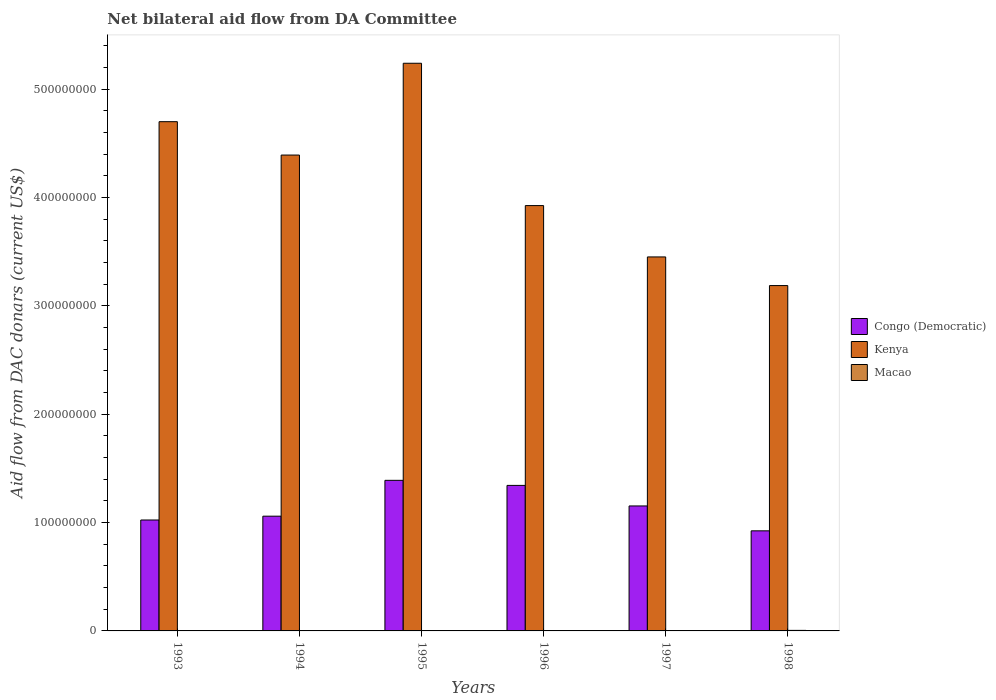Are the number of bars per tick equal to the number of legend labels?
Keep it short and to the point. Yes. How many bars are there on the 3rd tick from the right?
Provide a short and direct response. 3. What is the label of the 5th group of bars from the left?
Provide a short and direct response. 1997. In how many cases, is the number of bars for a given year not equal to the number of legend labels?
Your answer should be very brief. 0. What is the aid flow in in Kenya in 1997?
Ensure brevity in your answer.  3.45e+08. Across all years, what is the maximum aid flow in in Congo (Democratic)?
Your response must be concise. 1.39e+08. Across all years, what is the minimum aid flow in in Congo (Democratic)?
Provide a succinct answer. 9.24e+07. In which year was the aid flow in in Congo (Democratic) maximum?
Provide a short and direct response. 1995. What is the total aid flow in in Congo (Democratic) in the graph?
Provide a succinct answer. 6.89e+08. What is the difference between the aid flow in in Macao in 1993 and that in 1996?
Your answer should be compact. -1.40e+05. What is the difference between the aid flow in in Macao in 1996 and the aid flow in in Kenya in 1994?
Provide a succinct answer. -4.39e+08. What is the average aid flow in in Congo (Democratic) per year?
Provide a short and direct response. 1.15e+08. In the year 1994, what is the difference between the aid flow in in Kenya and aid flow in in Congo (Democratic)?
Ensure brevity in your answer.  3.33e+08. What is the ratio of the aid flow in in Kenya in 1995 to that in 1997?
Provide a short and direct response. 1.52. Is the difference between the aid flow in in Kenya in 1993 and 1995 greater than the difference between the aid flow in in Congo (Democratic) in 1993 and 1995?
Keep it short and to the point. No. What is the difference between the highest and the second highest aid flow in in Congo (Democratic)?
Make the answer very short. 4.68e+06. What is the difference between the highest and the lowest aid flow in in Kenya?
Give a very brief answer. 2.05e+08. What does the 1st bar from the left in 1998 represents?
Provide a succinct answer. Congo (Democratic). What does the 2nd bar from the right in 1996 represents?
Your response must be concise. Kenya. How many bars are there?
Make the answer very short. 18. Are all the bars in the graph horizontal?
Give a very brief answer. No. How many years are there in the graph?
Offer a terse response. 6. What is the difference between two consecutive major ticks on the Y-axis?
Offer a very short reply. 1.00e+08. Does the graph contain any zero values?
Your answer should be very brief. No. Does the graph contain grids?
Keep it short and to the point. No. How many legend labels are there?
Give a very brief answer. 3. How are the legend labels stacked?
Your answer should be very brief. Vertical. What is the title of the graph?
Your answer should be very brief. Net bilateral aid flow from DA Committee. What is the label or title of the Y-axis?
Your answer should be compact. Aid flow from DAC donars (current US$). What is the Aid flow from DAC donars (current US$) in Congo (Democratic) in 1993?
Your answer should be very brief. 1.02e+08. What is the Aid flow from DAC donars (current US$) in Kenya in 1993?
Provide a short and direct response. 4.70e+08. What is the Aid flow from DAC donars (current US$) of Congo (Democratic) in 1994?
Offer a very short reply. 1.06e+08. What is the Aid flow from DAC donars (current US$) in Kenya in 1994?
Provide a short and direct response. 4.39e+08. What is the Aid flow from DAC donars (current US$) of Macao in 1994?
Provide a short and direct response. 2.70e+05. What is the Aid flow from DAC donars (current US$) in Congo (Democratic) in 1995?
Offer a very short reply. 1.39e+08. What is the Aid flow from DAC donars (current US$) in Kenya in 1995?
Provide a short and direct response. 5.24e+08. What is the Aid flow from DAC donars (current US$) in Macao in 1995?
Offer a very short reply. 1.40e+05. What is the Aid flow from DAC donars (current US$) in Congo (Democratic) in 1996?
Give a very brief answer. 1.34e+08. What is the Aid flow from DAC donars (current US$) in Kenya in 1996?
Provide a short and direct response. 3.93e+08. What is the Aid flow from DAC donars (current US$) of Macao in 1996?
Your response must be concise. 2.90e+05. What is the Aid flow from DAC donars (current US$) in Congo (Democratic) in 1997?
Ensure brevity in your answer.  1.15e+08. What is the Aid flow from DAC donars (current US$) in Kenya in 1997?
Make the answer very short. 3.45e+08. What is the Aid flow from DAC donars (current US$) in Macao in 1997?
Offer a terse response. 3.10e+05. What is the Aid flow from DAC donars (current US$) of Congo (Democratic) in 1998?
Offer a terse response. 9.24e+07. What is the Aid flow from DAC donars (current US$) of Kenya in 1998?
Provide a short and direct response. 3.19e+08. What is the Aid flow from DAC donars (current US$) of Macao in 1998?
Offer a very short reply. 5.00e+05. Across all years, what is the maximum Aid flow from DAC donars (current US$) in Congo (Democratic)?
Offer a very short reply. 1.39e+08. Across all years, what is the maximum Aid flow from DAC donars (current US$) in Kenya?
Your answer should be compact. 5.24e+08. Across all years, what is the minimum Aid flow from DAC donars (current US$) in Congo (Democratic)?
Offer a very short reply. 9.24e+07. Across all years, what is the minimum Aid flow from DAC donars (current US$) in Kenya?
Your answer should be compact. 3.19e+08. What is the total Aid flow from DAC donars (current US$) in Congo (Democratic) in the graph?
Provide a short and direct response. 6.89e+08. What is the total Aid flow from DAC donars (current US$) in Kenya in the graph?
Ensure brevity in your answer.  2.49e+09. What is the total Aid flow from DAC donars (current US$) in Macao in the graph?
Ensure brevity in your answer.  1.66e+06. What is the difference between the Aid flow from DAC donars (current US$) in Congo (Democratic) in 1993 and that in 1994?
Your answer should be very brief. -3.52e+06. What is the difference between the Aid flow from DAC donars (current US$) of Kenya in 1993 and that in 1994?
Keep it short and to the point. 3.08e+07. What is the difference between the Aid flow from DAC donars (current US$) of Congo (Democratic) in 1993 and that in 1995?
Provide a succinct answer. -3.66e+07. What is the difference between the Aid flow from DAC donars (current US$) in Kenya in 1993 and that in 1995?
Provide a succinct answer. -5.39e+07. What is the difference between the Aid flow from DAC donars (current US$) in Congo (Democratic) in 1993 and that in 1996?
Offer a terse response. -3.19e+07. What is the difference between the Aid flow from DAC donars (current US$) of Kenya in 1993 and that in 1996?
Ensure brevity in your answer.  7.74e+07. What is the difference between the Aid flow from DAC donars (current US$) in Congo (Democratic) in 1993 and that in 1997?
Offer a very short reply. -1.30e+07. What is the difference between the Aid flow from DAC donars (current US$) in Kenya in 1993 and that in 1997?
Ensure brevity in your answer.  1.25e+08. What is the difference between the Aid flow from DAC donars (current US$) in Macao in 1993 and that in 1997?
Provide a succinct answer. -1.60e+05. What is the difference between the Aid flow from DAC donars (current US$) in Congo (Democratic) in 1993 and that in 1998?
Provide a succinct answer. 1.00e+07. What is the difference between the Aid flow from DAC donars (current US$) of Kenya in 1993 and that in 1998?
Your answer should be compact. 1.51e+08. What is the difference between the Aid flow from DAC donars (current US$) in Macao in 1993 and that in 1998?
Give a very brief answer. -3.50e+05. What is the difference between the Aid flow from DAC donars (current US$) of Congo (Democratic) in 1994 and that in 1995?
Give a very brief answer. -3.31e+07. What is the difference between the Aid flow from DAC donars (current US$) of Kenya in 1994 and that in 1995?
Your answer should be very brief. -8.47e+07. What is the difference between the Aid flow from DAC donars (current US$) of Macao in 1994 and that in 1995?
Keep it short and to the point. 1.30e+05. What is the difference between the Aid flow from DAC donars (current US$) in Congo (Democratic) in 1994 and that in 1996?
Your response must be concise. -2.84e+07. What is the difference between the Aid flow from DAC donars (current US$) in Kenya in 1994 and that in 1996?
Ensure brevity in your answer.  4.66e+07. What is the difference between the Aid flow from DAC donars (current US$) in Macao in 1994 and that in 1996?
Provide a short and direct response. -2.00e+04. What is the difference between the Aid flow from DAC donars (current US$) in Congo (Democratic) in 1994 and that in 1997?
Provide a succinct answer. -9.44e+06. What is the difference between the Aid flow from DAC donars (current US$) of Kenya in 1994 and that in 1997?
Provide a short and direct response. 9.40e+07. What is the difference between the Aid flow from DAC donars (current US$) of Macao in 1994 and that in 1997?
Keep it short and to the point. -4.00e+04. What is the difference between the Aid flow from DAC donars (current US$) of Congo (Democratic) in 1994 and that in 1998?
Give a very brief answer. 1.35e+07. What is the difference between the Aid flow from DAC donars (current US$) of Kenya in 1994 and that in 1998?
Make the answer very short. 1.20e+08. What is the difference between the Aid flow from DAC donars (current US$) of Macao in 1994 and that in 1998?
Offer a terse response. -2.30e+05. What is the difference between the Aid flow from DAC donars (current US$) in Congo (Democratic) in 1995 and that in 1996?
Ensure brevity in your answer.  4.68e+06. What is the difference between the Aid flow from DAC donars (current US$) of Kenya in 1995 and that in 1996?
Make the answer very short. 1.31e+08. What is the difference between the Aid flow from DAC donars (current US$) of Macao in 1995 and that in 1996?
Your response must be concise. -1.50e+05. What is the difference between the Aid flow from DAC donars (current US$) in Congo (Democratic) in 1995 and that in 1997?
Provide a succinct answer. 2.36e+07. What is the difference between the Aid flow from DAC donars (current US$) of Kenya in 1995 and that in 1997?
Offer a terse response. 1.79e+08. What is the difference between the Aid flow from DAC donars (current US$) of Macao in 1995 and that in 1997?
Your answer should be very brief. -1.70e+05. What is the difference between the Aid flow from DAC donars (current US$) in Congo (Democratic) in 1995 and that in 1998?
Ensure brevity in your answer.  4.66e+07. What is the difference between the Aid flow from DAC donars (current US$) in Kenya in 1995 and that in 1998?
Offer a very short reply. 2.05e+08. What is the difference between the Aid flow from DAC donars (current US$) in Macao in 1995 and that in 1998?
Offer a terse response. -3.60e+05. What is the difference between the Aid flow from DAC donars (current US$) of Congo (Democratic) in 1996 and that in 1997?
Offer a terse response. 1.90e+07. What is the difference between the Aid flow from DAC donars (current US$) in Kenya in 1996 and that in 1997?
Your answer should be very brief. 4.74e+07. What is the difference between the Aid flow from DAC donars (current US$) of Macao in 1996 and that in 1997?
Your response must be concise. -2.00e+04. What is the difference between the Aid flow from DAC donars (current US$) in Congo (Democratic) in 1996 and that in 1998?
Your answer should be compact. 4.19e+07. What is the difference between the Aid flow from DAC donars (current US$) in Kenya in 1996 and that in 1998?
Your answer should be very brief. 7.38e+07. What is the difference between the Aid flow from DAC donars (current US$) in Macao in 1996 and that in 1998?
Keep it short and to the point. -2.10e+05. What is the difference between the Aid flow from DAC donars (current US$) in Congo (Democratic) in 1997 and that in 1998?
Provide a succinct answer. 2.30e+07. What is the difference between the Aid flow from DAC donars (current US$) of Kenya in 1997 and that in 1998?
Offer a very short reply. 2.64e+07. What is the difference between the Aid flow from DAC donars (current US$) of Congo (Democratic) in 1993 and the Aid flow from DAC donars (current US$) of Kenya in 1994?
Provide a short and direct response. -3.37e+08. What is the difference between the Aid flow from DAC donars (current US$) in Congo (Democratic) in 1993 and the Aid flow from DAC donars (current US$) in Macao in 1994?
Your answer should be very brief. 1.02e+08. What is the difference between the Aid flow from DAC donars (current US$) of Kenya in 1993 and the Aid flow from DAC donars (current US$) of Macao in 1994?
Make the answer very short. 4.70e+08. What is the difference between the Aid flow from DAC donars (current US$) of Congo (Democratic) in 1993 and the Aid flow from DAC donars (current US$) of Kenya in 1995?
Your answer should be compact. -4.22e+08. What is the difference between the Aid flow from DAC donars (current US$) of Congo (Democratic) in 1993 and the Aid flow from DAC donars (current US$) of Macao in 1995?
Offer a very short reply. 1.02e+08. What is the difference between the Aid flow from DAC donars (current US$) in Kenya in 1993 and the Aid flow from DAC donars (current US$) in Macao in 1995?
Your answer should be compact. 4.70e+08. What is the difference between the Aid flow from DAC donars (current US$) of Congo (Democratic) in 1993 and the Aid flow from DAC donars (current US$) of Kenya in 1996?
Ensure brevity in your answer.  -2.90e+08. What is the difference between the Aid flow from DAC donars (current US$) of Congo (Democratic) in 1993 and the Aid flow from DAC donars (current US$) of Macao in 1996?
Your answer should be compact. 1.02e+08. What is the difference between the Aid flow from DAC donars (current US$) of Kenya in 1993 and the Aid flow from DAC donars (current US$) of Macao in 1996?
Provide a succinct answer. 4.70e+08. What is the difference between the Aid flow from DAC donars (current US$) in Congo (Democratic) in 1993 and the Aid flow from DAC donars (current US$) in Kenya in 1997?
Offer a terse response. -2.43e+08. What is the difference between the Aid flow from DAC donars (current US$) in Congo (Democratic) in 1993 and the Aid flow from DAC donars (current US$) in Macao in 1997?
Your answer should be very brief. 1.02e+08. What is the difference between the Aid flow from DAC donars (current US$) in Kenya in 1993 and the Aid flow from DAC donars (current US$) in Macao in 1997?
Provide a succinct answer. 4.70e+08. What is the difference between the Aid flow from DAC donars (current US$) of Congo (Democratic) in 1993 and the Aid flow from DAC donars (current US$) of Kenya in 1998?
Ensure brevity in your answer.  -2.16e+08. What is the difference between the Aid flow from DAC donars (current US$) in Congo (Democratic) in 1993 and the Aid flow from DAC donars (current US$) in Macao in 1998?
Offer a very short reply. 1.02e+08. What is the difference between the Aid flow from DAC donars (current US$) in Kenya in 1993 and the Aid flow from DAC donars (current US$) in Macao in 1998?
Ensure brevity in your answer.  4.69e+08. What is the difference between the Aid flow from DAC donars (current US$) in Congo (Democratic) in 1994 and the Aid flow from DAC donars (current US$) in Kenya in 1995?
Give a very brief answer. -4.18e+08. What is the difference between the Aid flow from DAC donars (current US$) of Congo (Democratic) in 1994 and the Aid flow from DAC donars (current US$) of Macao in 1995?
Your response must be concise. 1.06e+08. What is the difference between the Aid flow from DAC donars (current US$) of Kenya in 1994 and the Aid flow from DAC donars (current US$) of Macao in 1995?
Your answer should be very brief. 4.39e+08. What is the difference between the Aid flow from DAC donars (current US$) of Congo (Democratic) in 1994 and the Aid flow from DAC donars (current US$) of Kenya in 1996?
Keep it short and to the point. -2.87e+08. What is the difference between the Aid flow from DAC donars (current US$) of Congo (Democratic) in 1994 and the Aid flow from DAC donars (current US$) of Macao in 1996?
Ensure brevity in your answer.  1.06e+08. What is the difference between the Aid flow from DAC donars (current US$) of Kenya in 1994 and the Aid flow from DAC donars (current US$) of Macao in 1996?
Your answer should be very brief. 4.39e+08. What is the difference between the Aid flow from DAC donars (current US$) of Congo (Democratic) in 1994 and the Aid flow from DAC donars (current US$) of Kenya in 1997?
Keep it short and to the point. -2.39e+08. What is the difference between the Aid flow from DAC donars (current US$) of Congo (Democratic) in 1994 and the Aid flow from DAC donars (current US$) of Macao in 1997?
Provide a succinct answer. 1.06e+08. What is the difference between the Aid flow from DAC donars (current US$) in Kenya in 1994 and the Aid flow from DAC donars (current US$) in Macao in 1997?
Make the answer very short. 4.39e+08. What is the difference between the Aid flow from DAC donars (current US$) in Congo (Democratic) in 1994 and the Aid flow from DAC donars (current US$) in Kenya in 1998?
Give a very brief answer. -2.13e+08. What is the difference between the Aid flow from DAC donars (current US$) of Congo (Democratic) in 1994 and the Aid flow from DAC donars (current US$) of Macao in 1998?
Offer a very short reply. 1.05e+08. What is the difference between the Aid flow from DAC donars (current US$) of Kenya in 1994 and the Aid flow from DAC donars (current US$) of Macao in 1998?
Provide a short and direct response. 4.39e+08. What is the difference between the Aid flow from DAC donars (current US$) of Congo (Democratic) in 1995 and the Aid flow from DAC donars (current US$) of Kenya in 1996?
Ensure brevity in your answer.  -2.54e+08. What is the difference between the Aid flow from DAC donars (current US$) in Congo (Democratic) in 1995 and the Aid flow from DAC donars (current US$) in Macao in 1996?
Provide a succinct answer. 1.39e+08. What is the difference between the Aid flow from DAC donars (current US$) in Kenya in 1995 and the Aid flow from DAC donars (current US$) in Macao in 1996?
Your answer should be compact. 5.24e+08. What is the difference between the Aid flow from DAC donars (current US$) in Congo (Democratic) in 1995 and the Aid flow from DAC donars (current US$) in Kenya in 1997?
Make the answer very short. -2.06e+08. What is the difference between the Aid flow from DAC donars (current US$) in Congo (Democratic) in 1995 and the Aid flow from DAC donars (current US$) in Macao in 1997?
Make the answer very short. 1.39e+08. What is the difference between the Aid flow from DAC donars (current US$) of Kenya in 1995 and the Aid flow from DAC donars (current US$) of Macao in 1997?
Offer a terse response. 5.24e+08. What is the difference between the Aid flow from DAC donars (current US$) of Congo (Democratic) in 1995 and the Aid flow from DAC donars (current US$) of Kenya in 1998?
Offer a very short reply. -1.80e+08. What is the difference between the Aid flow from DAC donars (current US$) in Congo (Democratic) in 1995 and the Aid flow from DAC donars (current US$) in Macao in 1998?
Make the answer very short. 1.38e+08. What is the difference between the Aid flow from DAC donars (current US$) of Kenya in 1995 and the Aid flow from DAC donars (current US$) of Macao in 1998?
Offer a very short reply. 5.23e+08. What is the difference between the Aid flow from DAC donars (current US$) in Congo (Democratic) in 1996 and the Aid flow from DAC donars (current US$) in Kenya in 1997?
Your answer should be compact. -2.11e+08. What is the difference between the Aid flow from DAC donars (current US$) in Congo (Democratic) in 1996 and the Aid flow from DAC donars (current US$) in Macao in 1997?
Keep it short and to the point. 1.34e+08. What is the difference between the Aid flow from DAC donars (current US$) in Kenya in 1996 and the Aid flow from DAC donars (current US$) in Macao in 1997?
Your answer should be compact. 3.92e+08. What is the difference between the Aid flow from DAC donars (current US$) in Congo (Democratic) in 1996 and the Aid flow from DAC donars (current US$) in Kenya in 1998?
Ensure brevity in your answer.  -1.84e+08. What is the difference between the Aid flow from DAC donars (current US$) of Congo (Democratic) in 1996 and the Aid flow from DAC donars (current US$) of Macao in 1998?
Keep it short and to the point. 1.34e+08. What is the difference between the Aid flow from DAC donars (current US$) of Kenya in 1996 and the Aid flow from DAC donars (current US$) of Macao in 1998?
Your answer should be very brief. 3.92e+08. What is the difference between the Aid flow from DAC donars (current US$) in Congo (Democratic) in 1997 and the Aid flow from DAC donars (current US$) in Kenya in 1998?
Ensure brevity in your answer.  -2.03e+08. What is the difference between the Aid flow from DAC donars (current US$) in Congo (Democratic) in 1997 and the Aid flow from DAC donars (current US$) in Macao in 1998?
Give a very brief answer. 1.15e+08. What is the difference between the Aid flow from DAC donars (current US$) in Kenya in 1997 and the Aid flow from DAC donars (current US$) in Macao in 1998?
Provide a succinct answer. 3.45e+08. What is the average Aid flow from DAC donars (current US$) in Congo (Democratic) per year?
Offer a very short reply. 1.15e+08. What is the average Aid flow from DAC donars (current US$) of Kenya per year?
Give a very brief answer. 4.15e+08. What is the average Aid flow from DAC donars (current US$) in Macao per year?
Provide a succinct answer. 2.77e+05. In the year 1993, what is the difference between the Aid flow from DAC donars (current US$) in Congo (Democratic) and Aid flow from DAC donars (current US$) in Kenya?
Provide a succinct answer. -3.68e+08. In the year 1993, what is the difference between the Aid flow from DAC donars (current US$) of Congo (Democratic) and Aid flow from DAC donars (current US$) of Macao?
Provide a short and direct response. 1.02e+08. In the year 1993, what is the difference between the Aid flow from DAC donars (current US$) in Kenya and Aid flow from DAC donars (current US$) in Macao?
Your answer should be very brief. 4.70e+08. In the year 1994, what is the difference between the Aid flow from DAC donars (current US$) in Congo (Democratic) and Aid flow from DAC donars (current US$) in Kenya?
Offer a terse response. -3.33e+08. In the year 1994, what is the difference between the Aid flow from DAC donars (current US$) in Congo (Democratic) and Aid flow from DAC donars (current US$) in Macao?
Ensure brevity in your answer.  1.06e+08. In the year 1994, what is the difference between the Aid flow from DAC donars (current US$) in Kenya and Aid flow from DAC donars (current US$) in Macao?
Ensure brevity in your answer.  4.39e+08. In the year 1995, what is the difference between the Aid flow from DAC donars (current US$) of Congo (Democratic) and Aid flow from DAC donars (current US$) of Kenya?
Give a very brief answer. -3.85e+08. In the year 1995, what is the difference between the Aid flow from DAC donars (current US$) in Congo (Democratic) and Aid flow from DAC donars (current US$) in Macao?
Your answer should be very brief. 1.39e+08. In the year 1995, what is the difference between the Aid flow from DAC donars (current US$) of Kenya and Aid flow from DAC donars (current US$) of Macao?
Provide a short and direct response. 5.24e+08. In the year 1996, what is the difference between the Aid flow from DAC donars (current US$) of Congo (Democratic) and Aid flow from DAC donars (current US$) of Kenya?
Your answer should be very brief. -2.58e+08. In the year 1996, what is the difference between the Aid flow from DAC donars (current US$) of Congo (Democratic) and Aid flow from DAC donars (current US$) of Macao?
Your answer should be compact. 1.34e+08. In the year 1996, what is the difference between the Aid flow from DAC donars (current US$) in Kenya and Aid flow from DAC donars (current US$) in Macao?
Ensure brevity in your answer.  3.92e+08. In the year 1997, what is the difference between the Aid flow from DAC donars (current US$) of Congo (Democratic) and Aid flow from DAC donars (current US$) of Kenya?
Ensure brevity in your answer.  -2.30e+08. In the year 1997, what is the difference between the Aid flow from DAC donars (current US$) in Congo (Democratic) and Aid flow from DAC donars (current US$) in Macao?
Give a very brief answer. 1.15e+08. In the year 1997, what is the difference between the Aid flow from DAC donars (current US$) in Kenya and Aid flow from DAC donars (current US$) in Macao?
Ensure brevity in your answer.  3.45e+08. In the year 1998, what is the difference between the Aid flow from DAC donars (current US$) in Congo (Democratic) and Aid flow from DAC donars (current US$) in Kenya?
Offer a very short reply. -2.26e+08. In the year 1998, what is the difference between the Aid flow from DAC donars (current US$) of Congo (Democratic) and Aid flow from DAC donars (current US$) of Macao?
Provide a succinct answer. 9.19e+07. In the year 1998, what is the difference between the Aid flow from DAC donars (current US$) of Kenya and Aid flow from DAC donars (current US$) of Macao?
Provide a succinct answer. 3.18e+08. What is the ratio of the Aid flow from DAC donars (current US$) of Congo (Democratic) in 1993 to that in 1994?
Provide a succinct answer. 0.97. What is the ratio of the Aid flow from DAC donars (current US$) of Kenya in 1993 to that in 1994?
Your answer should be very brief. 1.07. What is the ratio of the Aid flow from DAC donars (current US$) of Macao in 1993 to that in 1994?
Your answer should be very brief. 0.56. What is the ratio of the Aid flow from DAC donars (current US$) of Congo (Democratic) in 1993 to that in 1995?
Your response must be concise. 0.74. What is the ratio of the Aid flow from DAC donars (current US$) of Kenya in 1993 to that in 1995?
Your response must be concise. 0.9. What is the ratio of the Aid flow from DAC donars (current US$) in Macao in 1993 to that in 1995?
Keep it short and to the point. 1.07. What is the ratio of the Aid flow from DAC donars (current US$) of Congo (Democratic) in 1993 to that in 1996?
Your answer should be compact. 0.76. What is the ratio of the Aid flow from DAC donars (current US$) of Kenya in 1993 to that in 1996?
Give a very brief answer. 1.2. What is the ratio of the Aid flow from DAC donars (current US$) in Macao in 1993 to that in 1996?
Your answer should be very brief. 0.52. What is the ratio of the Aid flow from DAC donars (current US$) in Congo (Democratic) in 1993 to that in 1997?
Provide a short and direct response. 0.89. What is the ratio of the Aid flow from DAC donars (current US$) of Kenya in 1993 to that in 1997?
Your answer should be very brief. 1.36. What is the ratio of the Aid flow from DAC donars (current US$) in Macao in 1993 to that in 1997?
Your answer should be compact. 0.48. What is the ratio of the Aid flow from DAC donars (current US$) of Congo (Democratic) in 1993 to that in 1998?
Provide a short and direct response. 1.11. What is the ratio of the Aid flow from DAC donars (current US$) of Kenya in 1993 to that in 1998?
Offer a very short reply. 1.47. What is the ratio of the Aid flow from DAC donars (current US$) in Macao in 1993 to that in 1998?
Your answer should be very brief. 0.3. What is the ratio of the Aid flow from DAC donars (current US$) in Congo (Democratic) in 1994 to that in 1995?
Offer a very short reply. 0.76. What is the ratio of the Aid flow from DAC donars (current US$) of Kenya in 1994 to that in 1995?
Give a very brief answer. 0.84. What is the ratio of the Aid flow from DAC donars (current US$) in Macao in 1994 to that in 1995?
Provide a short and direct response. 1.93. What is the ratio of the Aid flow from DAC donars (current US$) in Congo (Democratic) in 1994 to that in 1996?
Provide a succinct answer. 0.79. What is the ratio of the Aid flow from DAC donars (current US$) in Kenya in 1994 to that in 1996?
Offer a very short reply. 1.12. What is the ratio of the Aid flow from DAC donars (current US$) of Congo (Democratic) in 1994 to that in 1997?
Your answer should be very brief. 0.92. What is the ratio of the Aid flow from DAC donars (current US$) in Kenya in 1994 to that in 1997?
Make the answer very short. 1.27. What is the ratio of the Aid flow from DAC donars (current US$) in Macao in 1994 to that in 1997?
Your answer should be very brief. 0.87. What is the ratio of the Aid flow from DAC donars (current US$) in Congo (Democratic) in 1994 to that in 1998?
Keep it short and to the point. 1.15. What is the ratio of the Aid flow from DAC donars (current US$) in Kenya in 1994 to that in 1998?
Your answer should be very brief. 1.38. What is the ratio of the Aid flow from DAC donars (current US$) in Macao in 1994 to that in 1998?
Give a very brief answer. 0.54. What is the ratio of the Aid flow from DAC donars (current US$) in Congo (Democratic) in 1995 to that in 1996?
Provide a succinct answer. 1.03. What is the ratio of the Aid flow from DAC donars (current US$) in Kenya in 1995 to that in 1996?
Make the answer very short. 1.33. What is the ratio of the Aid flow from DAC donars (current US$) of Macao in 1995 to that in 1996?
Keep it short and to the point. 0.48. What is the ratio of the Aid flow from DAC donars (current US$) of Congo (Democratic) in 1995 to that in 1997?
Make the answer very short. 1.21. What is the ratio of the Aid flow from DAC donars (current US$) of Kenya in 1995 to that in 1997?
Give a very brief answer. 1.52. What is the ratio of the Aid flow from DAC donars (current US$) of Macao in 1995 to that in 1997?
Offer a very short reply. 0.45. What is the ratio of the Aid flow from DAC donars (current US$) of Congo (Democratic) in 1995 to that in 1998?
Provide a short and direct response. 1.5. What is the ratio of the Aid flow from DAC donars (current US$) of Kenya in 1995 to that in 1998?
Ensure brevity in your answer.  1.64. What is the ratio of the Aid flow from DAC donars (current US$) of Macao in 1995 to that in 1998?
Your answer should be compact. 0.28. What is the ratio of the Aid flow from DAC donars (current US$) in Congo (Democratic) in 1996 to that in 1997?
Your answer should be compact. 1.16. What is the ratio of the Aid flow from DAC donars (current US$) in Kenya in 1996 to that in 1997?
Keep it short and to the point. 1.14. What is the ratio of the Aid flow from DAC donars (current US$) in Macao in 1996 to that in 1997?
Offer a very short reply. 0.94. What is the ratio of the Aid flow from DAC donars (current US$) of Congo (Democratic) in 1996 to that in 1998?
Offer a terse response. 1.45. What is the ratio of the Aid flow from DAC donars (current US$) of Kenya in 1996 to that in 1998?
Ensure brevity in your answer.  1.23. What is the ratio of the Aid flow from DAC donars (current US$) of Macao in 1996 to that in 1998?
Make the answer very short. 0.58. What is the ratio of the Aid flow from DAC donars (current US$) in Congo (Democratic) in 1997 to that in 1998?
Offer a terse response. 1.25. What is the ratio of the Aid flow from DAC donars (current US$) in Kenya in 1997 to that in 1998?
Your answer should be very brief. 1.08. What is the ratio of the Aid flow from DAC donars (current US$) in Macao in 1997 to that in 1998?
Your answer should be compact. 0.62. What is the difference between the highest and the second highest Aid flow from DAC donars (current US$) of Congo (Democratic)?
Make the answer very short. 4.68e+06. What is the difference between the highest and the second highest Aid flow from DAC donars (current US$) of Kenya?
Offer a terse response. 5.39e+07. What is the difference between the highest and the second highest Aid flow from DAC donars (current US$) in Macao?
Offer a terse response. 1.90e+05. What is the difference between the highest and the lowest Aid flow from DAC donars (current US$) in Congo (Democratic)?
Offer a terse response. 4.66e+07. What is the difference between the highest and the lowest Aid flow from DAC donars (current US$) in Kenya?
Give a very brief answer. 2.05e+08. What is the difference between the highest and the lowest Aid flow from DAC donars (current US$) in Macao?
Offer a very short reply. 3.60e+05. 